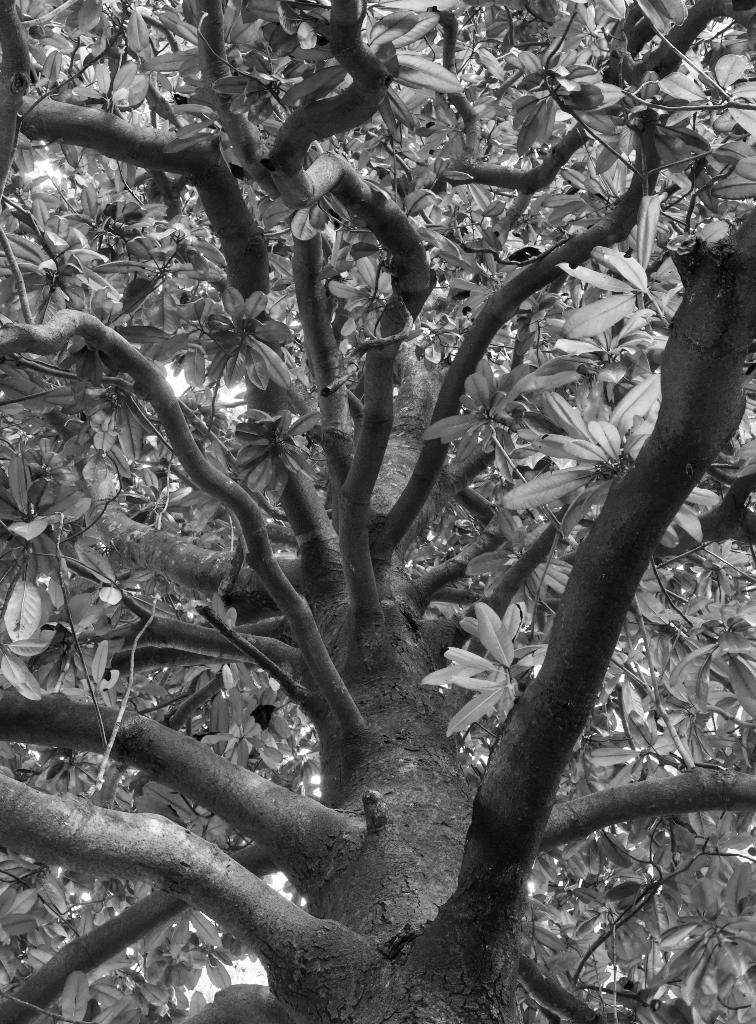Can you describe this image briefly? This is a zoom in picture of a tree as we can see there are some leaves in middle of this image. 